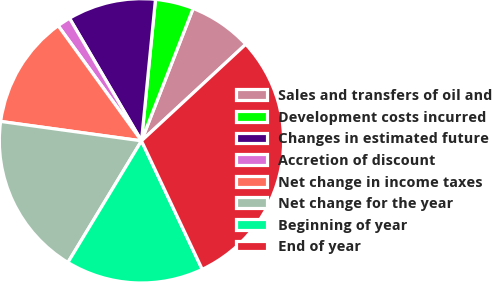<chart> <loc_0><loc_0><loc_500><loc_500><pie_chart><fcel>Sales and transfers of oil and<fcel>Development costs incurred<fcel>Changes in estimated future<fcel>Accretion of discount<fcel>Net change in income taxes<fcel>Net change for the year<fcel>Beginning of year<fcel>End of year<nl><fcel>7.19%<fcel>4.35%<fcel>10.02%<fcel>1.52%<fcel>12.85%<fcel>18.52%<fcel>15.69%<fcel>29.86%<nl></chart> 